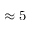<formula> <loc_0><loc_0><loc_500><loc_500>\approx 5</formula> 